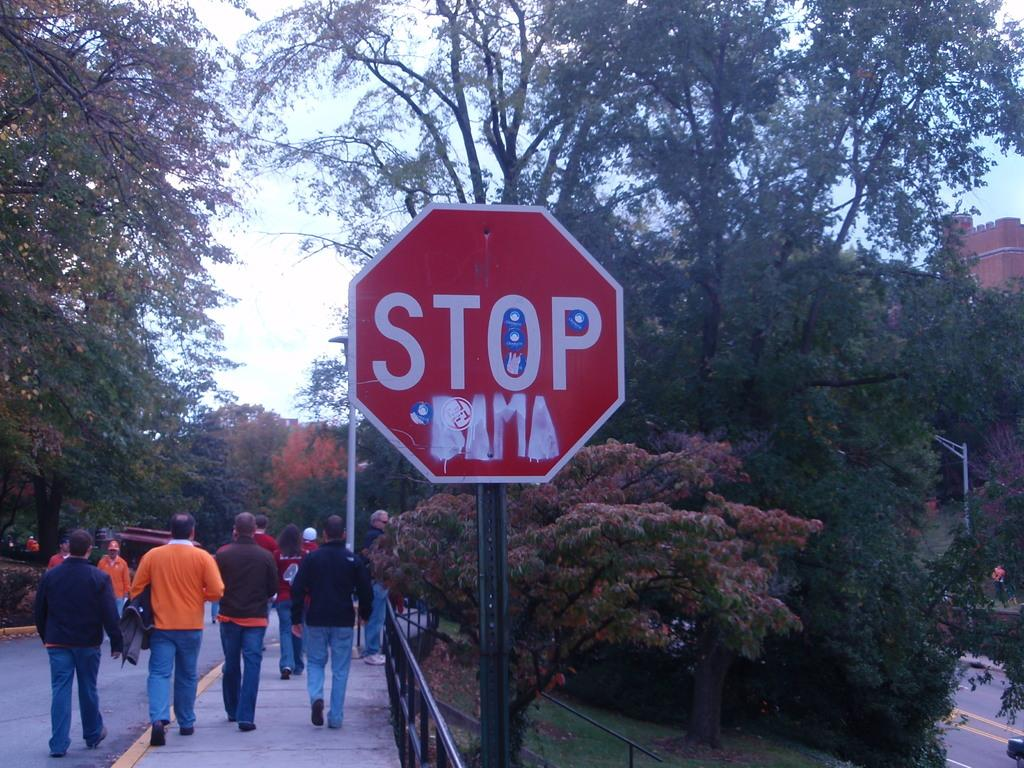<image>
Present a compact description of the photo's key features. A stop sign has Obama painted on it below the word stop. 